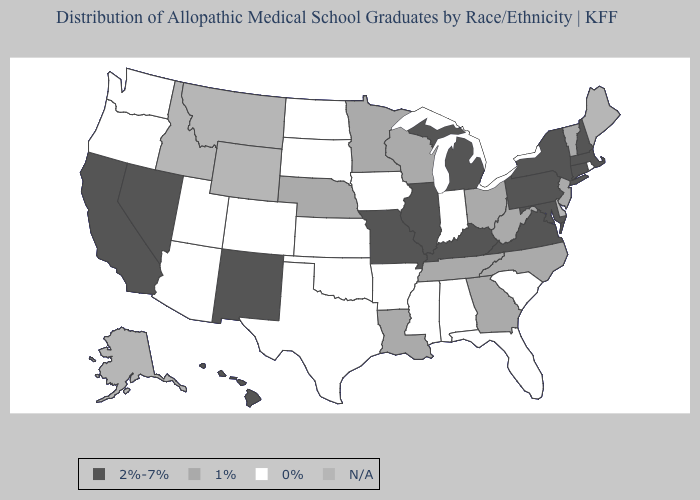Name the states that have a value in the range N/A?
Give a very brief answer. Alaska, Delaware, Idaho, Maine, Montana, Wyoming. What is the lowest value in states that border Vermont?
Give a very brief answer. 2%-7%. Among the states that border Utah , does Arizona have the lowest value?
Concise answer only. Yes. Among the states that border Arkansas , does Missouri have the lowest value?
Answer briefly. No. What is the lowest value in states that border Rhode Island?
Write a very short answer. 2%-7%. Which states have the lowest value in the West?
Answer briefly. Arizona, Colorado, Oregon, Utah, Washington. Among the states that border Pennsylvania , which have the highest value?
Short answer required. Maryland, New York. What is the value of Missouri?
Short answer required. 2%-7%. Does the map have missing data?
Answer briefly. Yes. Among the states that border Wisconsin , which have the lowest value?
Keep it brief. Iowa. Which states have the lowest value in the West?
Be succinct. Arizona, Colorado, Oregon, Utah, Washington. Is the legend a continuous bar?
Give a very brief answer. No. Among the states that border Oregon , does Washington have the lowest value?
Be succinct. Yes. What is the value of North Dakota?
Quick response, please. 0%. 